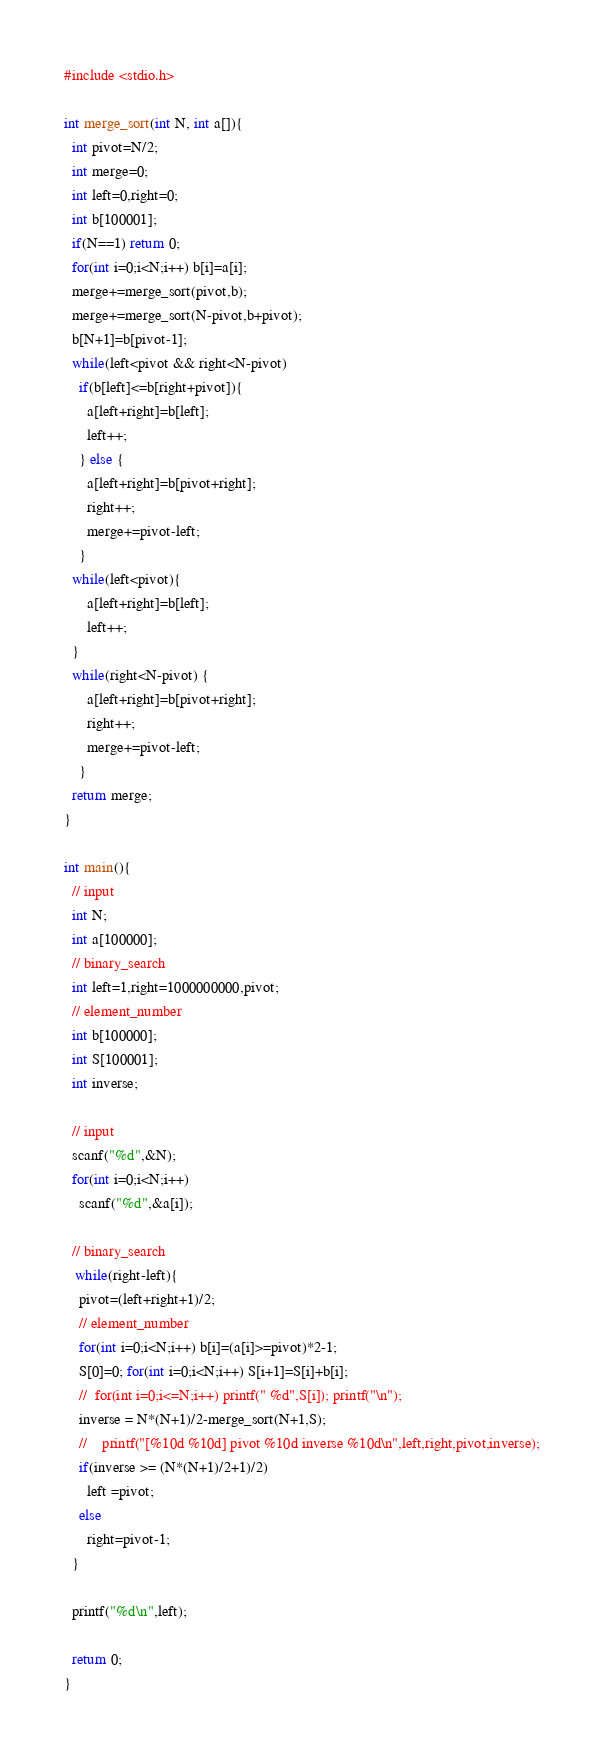<code> <loc_0><loc_0><loc_500><loc_500><_C_>#include <stdio.h>

int merge_sort(int N, int a[]){
  int pivot=N/2;
  int merge=0;
  int left=0,right=0;
  int b[100001];
  if(N==1) return 0;
  for(int i=0;i<N;i++) b[i]=a[i];
  merge+=merge_sort(pivot,b);
  merge+=merge_sort(N-pivot,b+pivot);
  b[N+1]=b[pivot-1];
  while(left<pivot && right<N-pivot)
    if(b[left]<=b[right+pivot]){
      a[left+right]=b[left];
      left++;
    } else {
      a[left+right]=b[pivot+right];
      right++;
      merge+=pivot-left;
    }
  while(left<pivot){
      a[left+right]=b[left];
      left++;
  }
  while(right<N-pivot) {
      a[left+right]=b[pivot+right];
      right++;
      merge+=pivot-left;
    }
  return merge;
}

int main(){
  // input
  int N;
  int a[100000];
  // binary_search
  int left=1,right=1000000000,pivot;
  // element_number
  int b[100000];
  int S[100001];
  int inverse;
  
  // input
  scanf("%d",&N);
  for(int i=0;i<N;i++)
    scanf("%d",&a[i]);

  // binary_search
   while(right-left){
    pivot=(left+right+1)/2;
    // element_number
    for(int i=0;i<N;i++) b[i]=(a[i]>=pivot)*2-1;
    S[0]=0; for(int i=0;i<N;i++) S[i+1]=S[i]+b[i];
    //  for(int i=0;i<=N;i++) printf(" %d",S[i]); printf("\n");
    inverse = N*(N+1)/2-merge_sort(N+1,S);
    //    printf("[%10d %10d] pivot %10d inverse %10d\n",left,right,pivot,inverse);
    if(inverse >= (N*(N+1)/2+1)/2)
      left =pivot;
    else
      right=pivot-1;
  }
    
  printf("%d\n",left);
  
  return 0;
}
</code> 